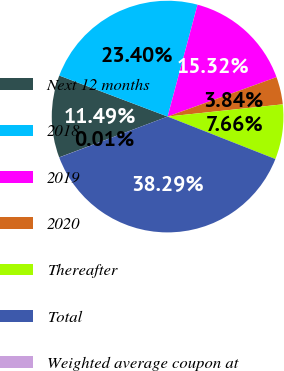<chart> <loc_0><loc_0><loc_500><loc_500><pie_chart><fcel>Next 12 months<fcel>2018<fcel>2019<fcel>2020<fcel>Thereafter<fcel>Total<fcel>Weighted average coupon at<nl><fcel>11.49%<fcel>23.4%<fcel>15.32%<fcel>3.84%<fcel>7.66%<fcel>38.29%<fcel>0.01%<nl></chart> 